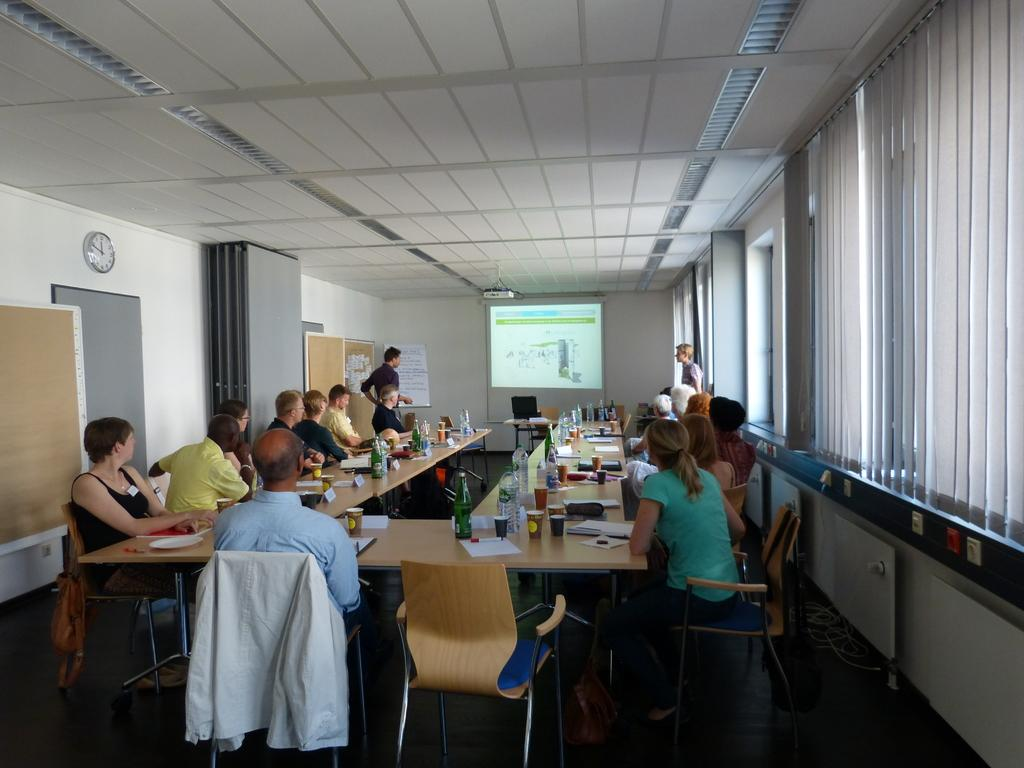What are the people in the image doing? The people are sitting on chairs around a table. What are the people looking at while sitting at the table? The people are looking at a screen on the wall. Where is the screen located in the image? The screen is on the wall. What can be seen on the right side of the image? There are windows with curtains on the right side of the image. How many hours does the party last in the image? There is no indication of a party in the image, so it is not possible to determine the duration of a party. 